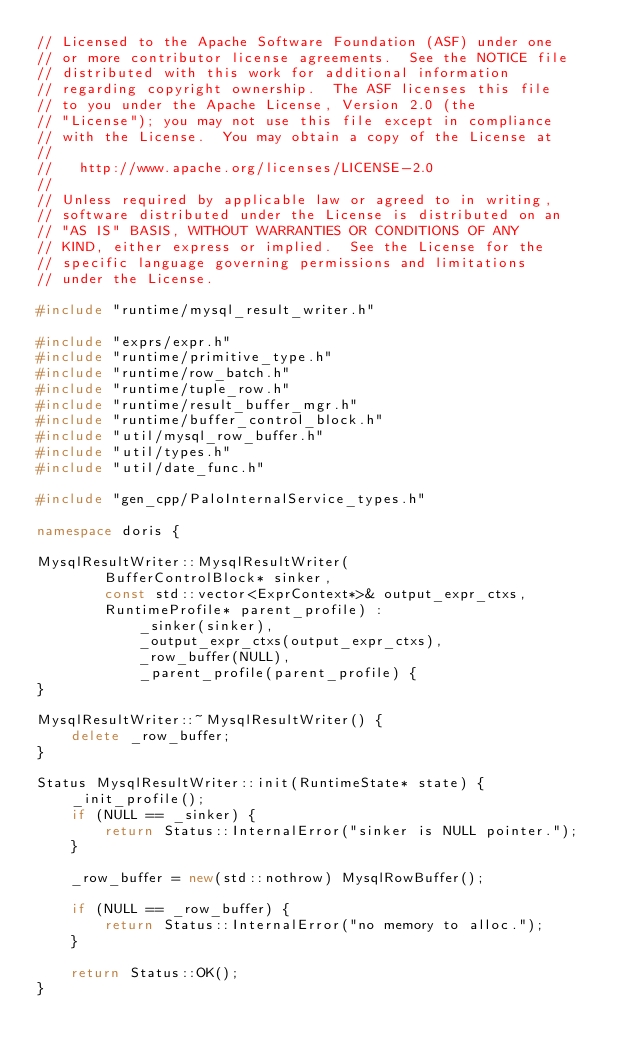Convert code to text. <code><loc_0><loc_0><loc_500><loc_500><_C++_>// Licensed to the Apache Software Foundation (ASF) under one
// or more contributor license agreements.  See the NOTICE file
// distributed with this work for additional information
// regarding copyright ownership.  The ASF licenses this file
// to you under the Apache License, Version 2.0 (the
// "License"); you may not use this file except in compliance
// with the License.  You may obtain a copy of the License at
//
//   http://www.apache.org/licenses/LICENSE-2.0
//
// Unless required by applicable law or agreed to in writing,
// software distributed under the License is distributed on an
// "AS IS" BASIS, WITHOUT WARRANTIES OR CONDITIONS OF ANY
// KIND, either express or implied.  See the License for the
// specific language governing permissions and limitations
// under the License.

#include "runtime/mysql_result_writer.h"

#include "exprs/expr.h"
#include "runtime/primitive_type.h"
#include "runtime/row_batch.h"
#include "runtime/tuple_row.h"
#include "runtime/result_buffer_mgr.h"
#include "runtime/buffer_control_block.h"
#include "util/mysql_row_buffer.h"
#include "util/types.h"
#include "util/date_func.h"

#include "gen_cpp/PaloInternalService_types.h"

namespace doris {

MysqlResultWriter::MysqlResultWriter(
        BufferControlBlock* sinker,
        const std::vector<ExprContext*>& output_expr_ctxs,
        RuntimeProfile* parent_profile) :
            _sinker(sinker),
            _output_expr_ctxs(output_expr_ctxs),
            _row_buffer(NULL),
            _parent_profile(parent_profile) {
}

MysqlResultWriter::~MysqlResultWriter() {
    delete _row_buffer;
}

Status MysqlResultWriter::init(RuntimeState* state) {
    _init_profile();
    if (NULL == _sinker) {
        return Status::InternalError("sinker is NULL pointer.");
    }

    _row_buffer = new(std::nothrow) MysqlRowBuffer();

    if (NULL == _row_buffer) {
        return Status::InternalError("no memory to alloc.");
    }

    return Status::OK();
}
</code> 